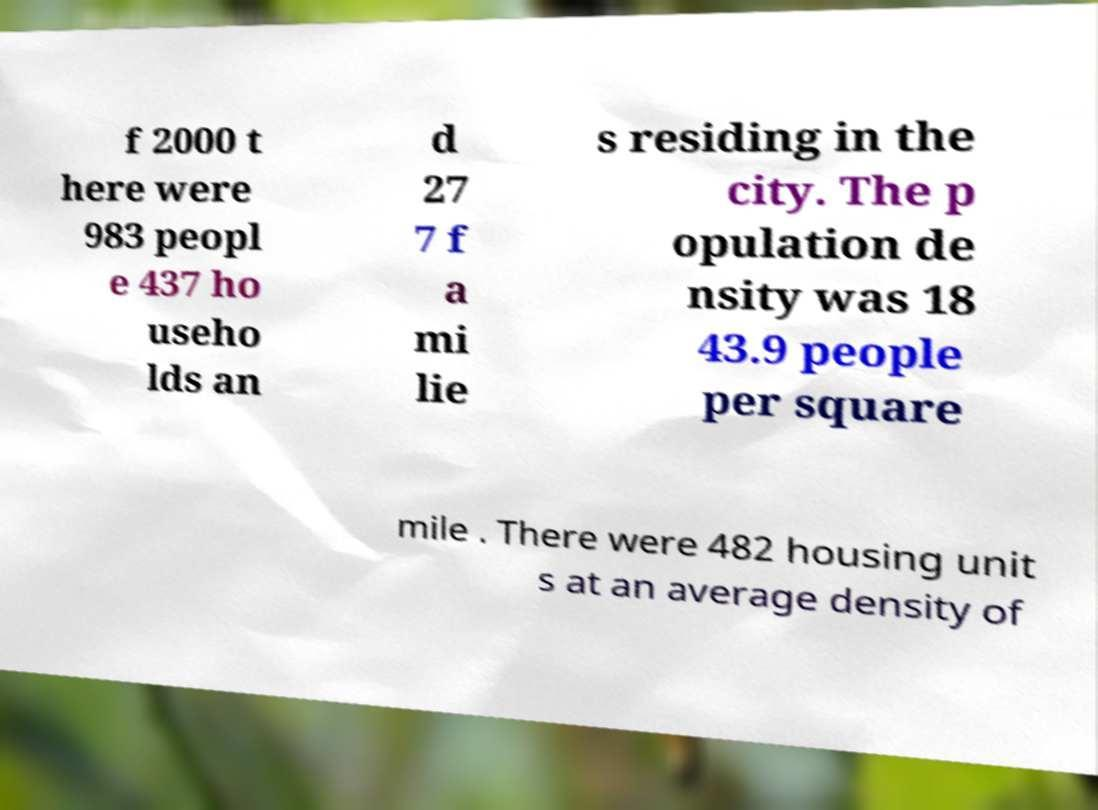Can you read and provide the text displayed in the image?This photo seems to have some interesting text. Can you extract and type it out for me? f 2000 t here were 983 peopl e 437 ho useho lds an d 27 7 f a mi lie s residing in the city. The p opulation de nsity was 18 43.9 people per square mile . There were 482 housing unit s at an average density of 